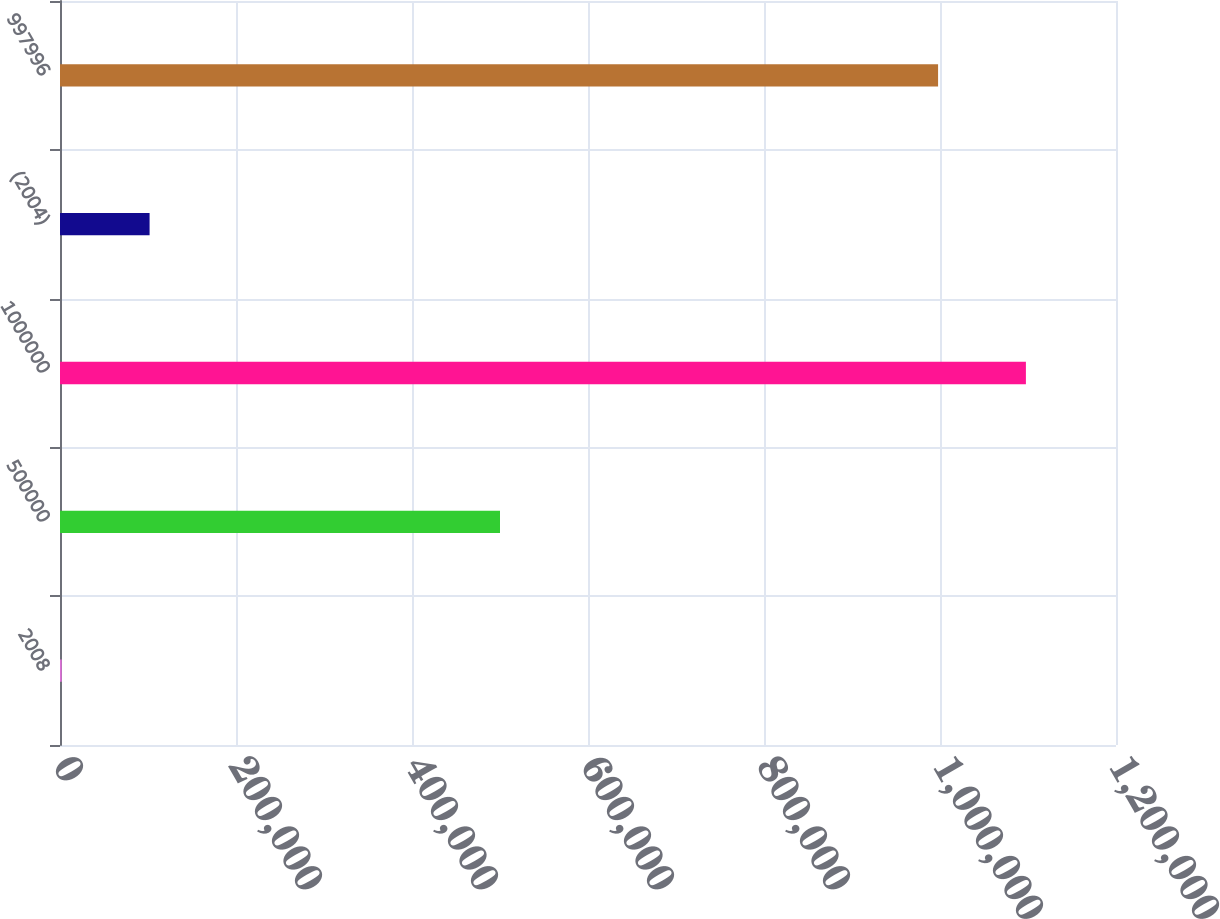Convert chart. <chart><loc_0><loc_0><loc_500><loc_500><bar_chart><fcel>2008<fcel>500000<fcel>1000000<fcel>(2004)<fcel>997996<nl><fcel>2007<fcel>500000<fcel>1.09762e+06<fcel>101806<fcel>997819<nl></chart> 